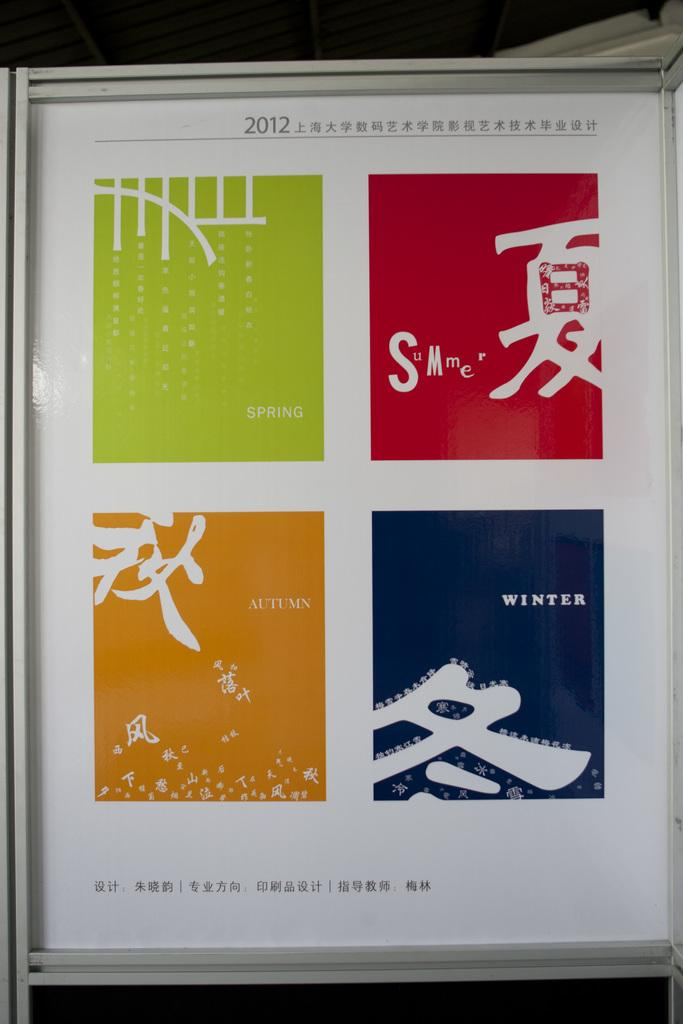<image>
Give a short and clear explanation of the subsequent image. An Asian sign with green, red, orange, and blue blocks on it and the date of 2012. 